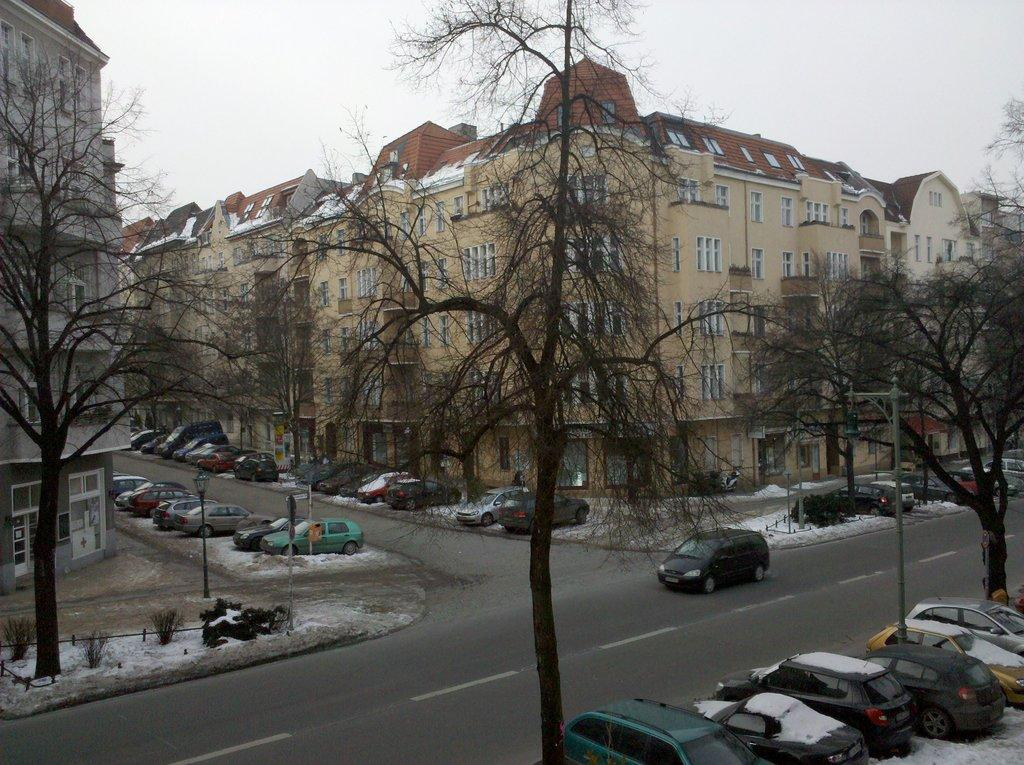What type of structures can be seen in the image? There are buildings in the image. What else can be seen on the ground in the image? There are vehicles on the road in the image. What type of natural elements are present in the image? There are trees in the image. What is the weather like in the image? There is snow visible in the image, indicating a cold or wintry environment. What is the tall, vertical object in the image? There is a light pole in the image. What is visible at the top of the image? The sky is visible at the top of the image. What type of disgust can be seen on the yoke of the scissors in the image? There are no scissors, yokes, or any indication of disgust present in the image. 